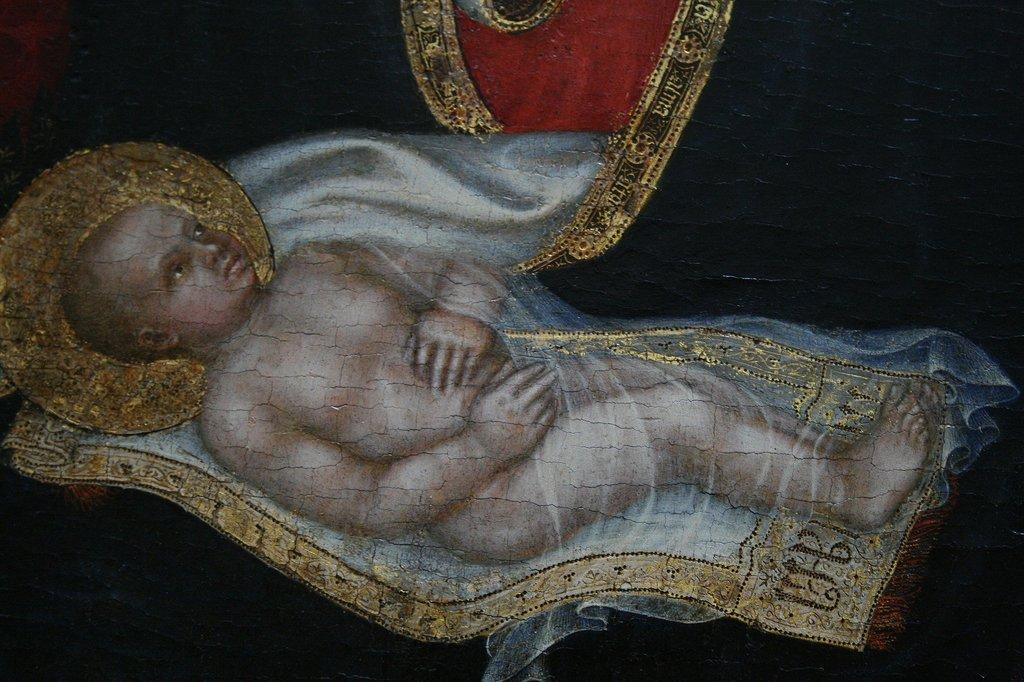What is the main subject of the image? The main subject of the image is a kid. What can be seen in the background of the image? The background of the image is black. What verse is the kid reading in the image? There is no indication in the image that the kid is reading any verse, as the facts do not mention any reading material or text. 